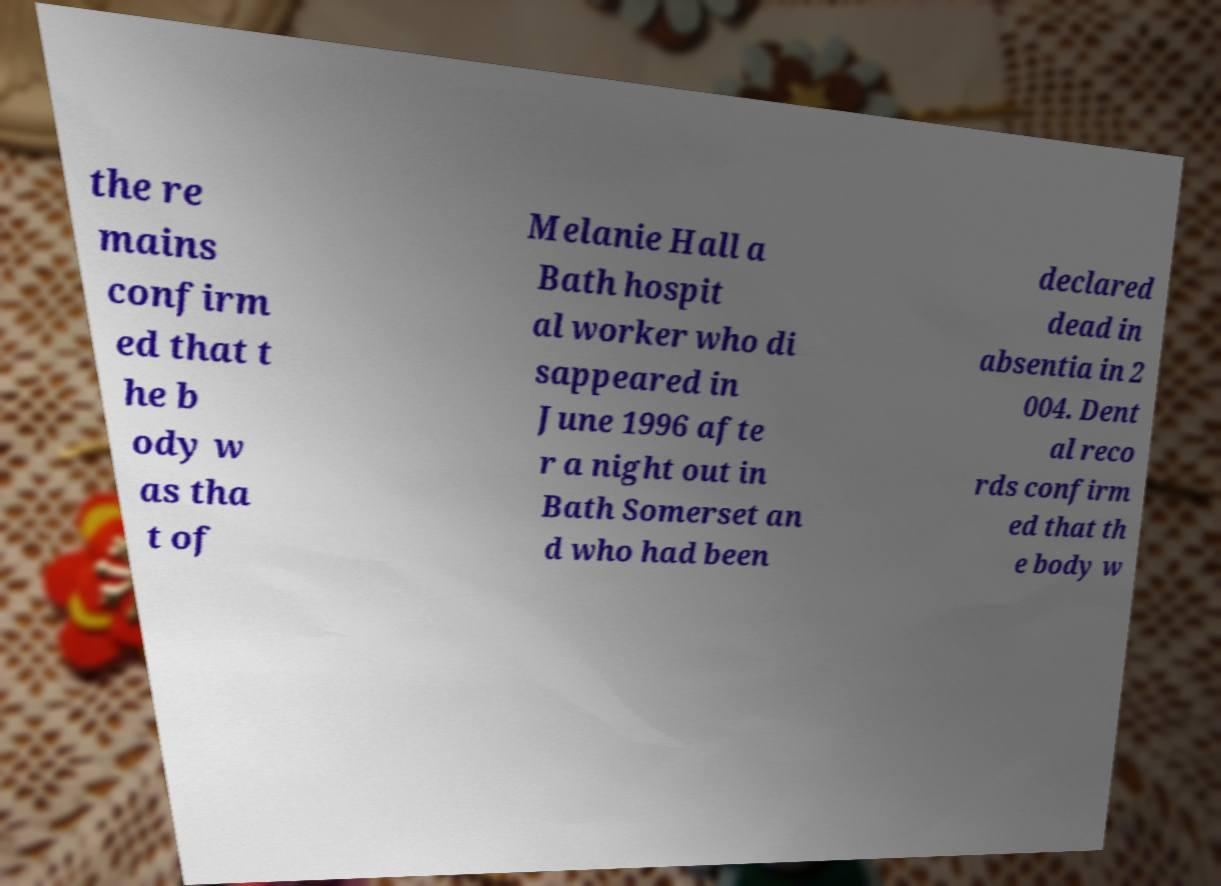Can you read and provide the text displayed in the image?This photo seems to have some interesting text. Can you extract and type it out for me? the re mains confirm ed that t he b ody w as tha t of Melanie Hall a Bath hospit al worker who di sappeared in June 1996 afte r a night out in Bath Somerset an d who had been declared dead in absentia in 2 004. Dent al reco rds confirm ed that th e body w 